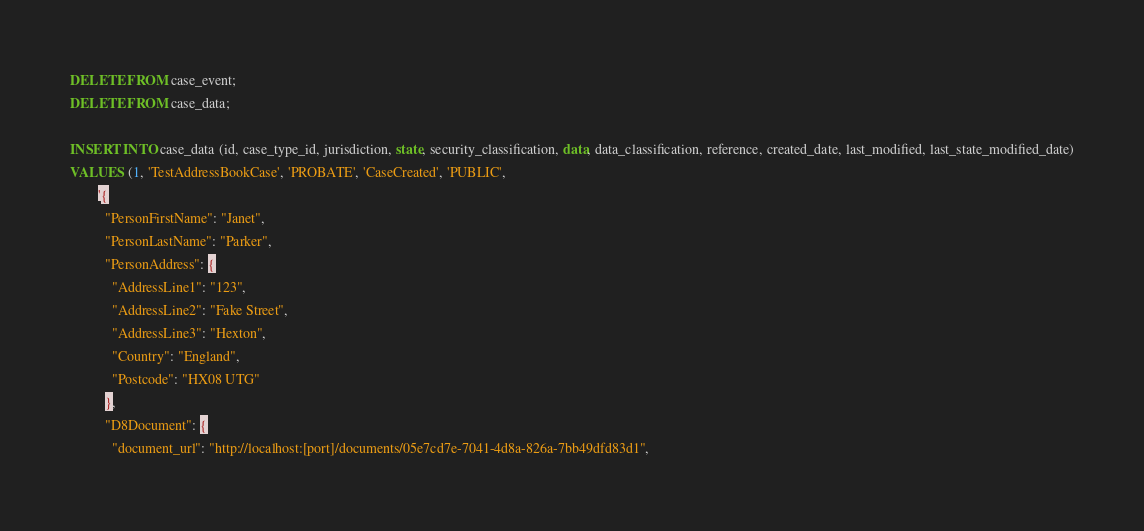<code> <loc_0><loc_0><loc_500><loc_500><_SQL_>DELETE FROM case_event;
DELETE FROM case_data;

INSERT INTO case_data (id, case_type_id, jurisdiction, state, security_classification, data, data_classification, reference, created_date, last_modified, last_state_modified_date)
VALUES (1, 'TestAddressBookCase', 'PROBATE', 'CaseCreated', 'PUBLIC',
        '{
          "PersonFirstName": "Janet",
          "PersonLastName": "Parker",
          "PersonAddress": {
            "AddressLine1": "123",
            "AddressLine2": "Fake Street",
            "AddressLine3": "Hexton",
            "Country": "England",
            "Postcode": "HX08 UTG"
          },
          "D8Document": {
            "document_url": "http://localhost:[port]/documents/05e7cd7e-7041-4d8a-826a-7bb49dfd83d1",</code> 